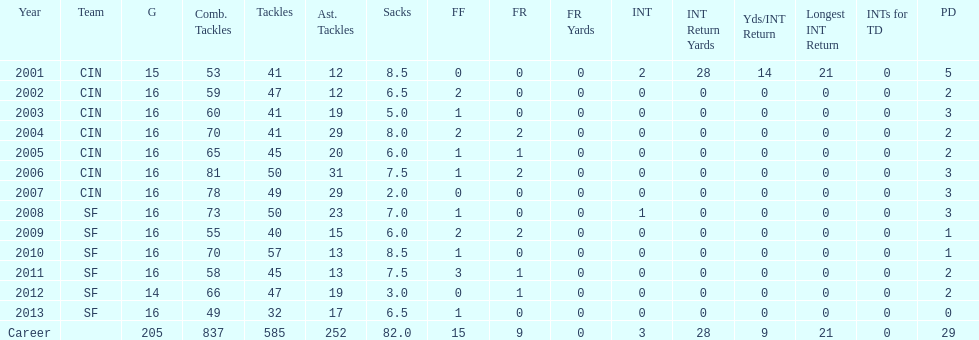What is the only season he has fewer than three sacks? 2007. 